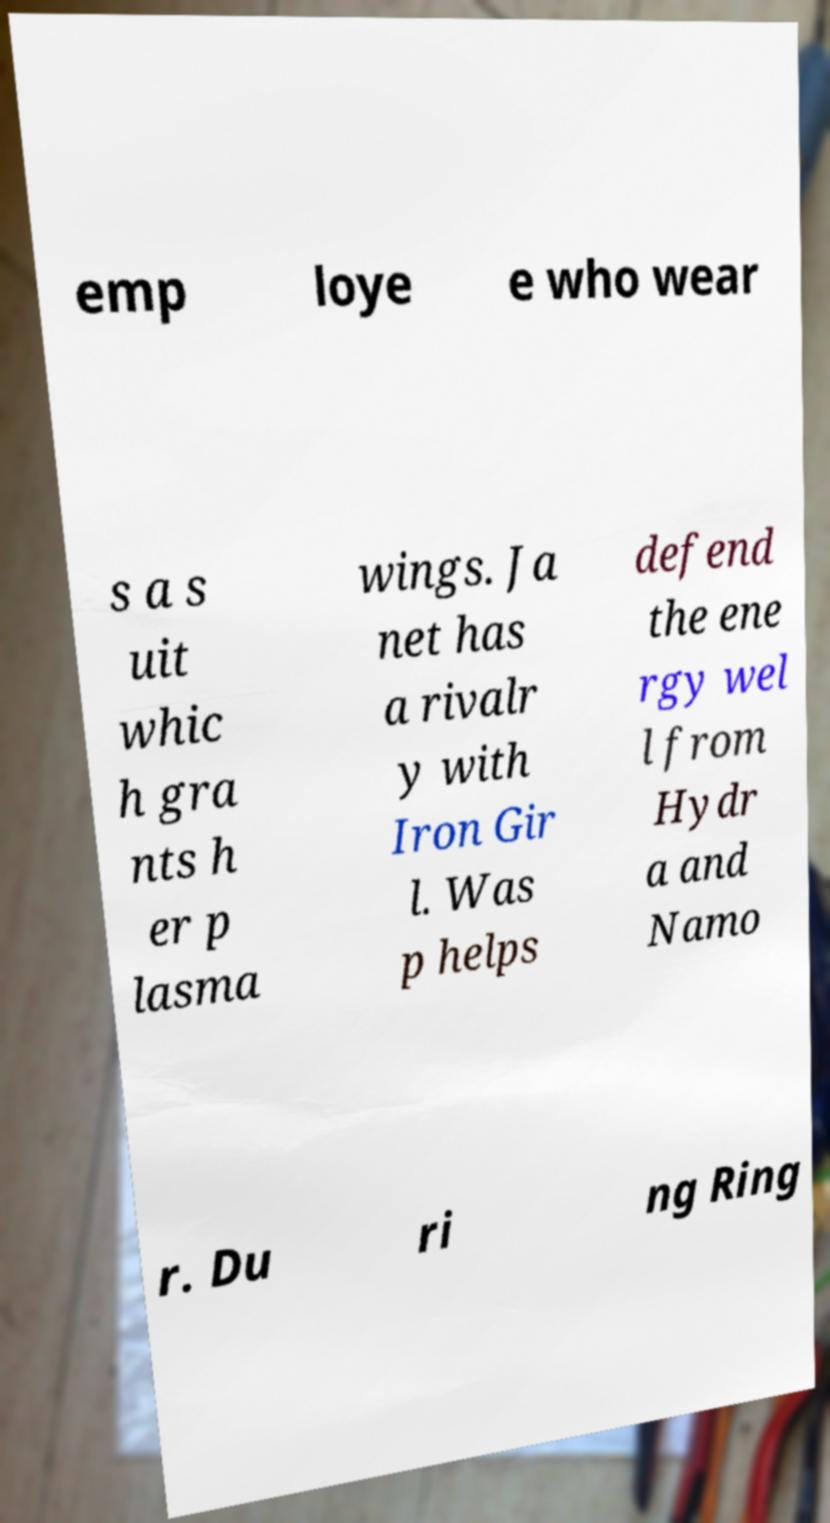I need the written content from this picture converted into text. Can you do that? emp loye e who wear s a s uit whic h gra nts h er p lasma wings. Ja net has a rivalr y with Iron Gir l. Was p helps defend the ene rgy wel l from Hydr a and Namo r. Du ri ng Ring 